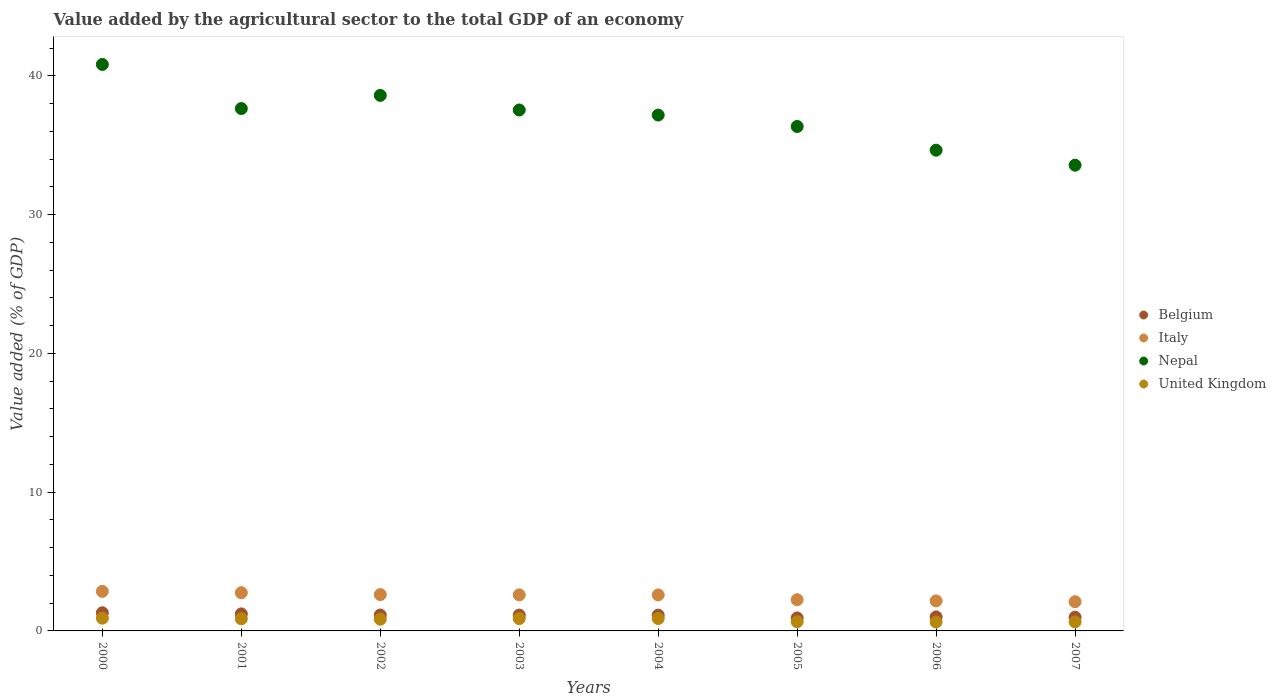Is the number of dotlines equal to the number of legend labels?
Keep it short and to the point. Yes. What is the value added by the agricultural sector to the total GDP in Nepal in 2005?
Ensure brevity in your answer.  36.35. Across all years, what is the maximum value added by the agricultural sector to the total GDP in Belgium?
Your answer should be compact. 1.31. Across all years, what is the minimum value added by the agricultural sector to the total GDP in Nepal?
Your answer should be compact. 33.56. In which year was the value added by the agricultural sector to the total GDP in Nepal maximum?
Offer a very short reply. 2000. What is the total value added by the agricultural sector to the total GDP in Nepal in the graph?
Your answer should be compact. 296.32. What is the difference between the value added by the agricultural sector to the total GDP in Italy in 2001 and that in 2007?
Offer a very short reply. 0.65. What is the difference between the value added by the agricultural sector to the total GDP in United Kingdom in 2006 and the value added by the agricultural sector to the total GDP in Italy in 2001?
Make the answer very short. -2.11. What is the average value added by the agricultural sector to the total GDP in Italy per year?
Your answer should be compact. 2.49. In the year 2003, what is the difference between the value added by the agricultural sector to the total GDP in Italy and value added by the agricultural sector to the total GDP in United Kingdom?
Offer a terse response. 1.71. In how many years, is the value added by the agricultural sector to the total GDP in Nepal greater than 40 %?
Your answer should be compact. 1. What is the ratio of the value added by the agricultural sector to the total GDP in Italy in 2000 to that in 2001?
Provide a short and direct response. 1.03. What is the difference between the highest and the second highest value added by the agricultural sector to the total GDP in United Kingdom?
Make the answer very short. 0.02. What is the difference between the highest and the lowest value added by the agricultural sector to the total GDP in United Kingdom?
Your answer should be compact. 0.28. In how many years, is the value added by the agricultural sector to the total GDP in United Kingdom greater than the average value added by the agricultural sector to the total GDP in United Kingdom taken over all years?
Ensure brevity in your answer.  5. Is the value added by the agricultural sector to the total GDP in Nepal strictly greater than the value added by the agricultural sector to the total GDP in Italy over the years?
Your answer should be compact. Yes. Is the value added by the agricultural sector to the total GDP in Nepal strictly less than the value added by the agricultural sector to the total GDP in Italy over the years?
Offer a terse response. No. How many dotlines are there?
Your response must be concise. 4. Are the values on the major ticks of Y-axis written in scientific E-notation?
Your response must be concise. No. How many legend labels are there?
Provide a succinct answer. 4. How are the legend labels stacked?
Provide a succinct answer. Vertical. What is the title of the graph?
Your answer should be compact. Value added by the agricultural sector to the total GDP of an economy. Does "Caribbean small states" appear as one of the legend labels in the graph?
Your response must be concise. No. What is the label or title of the X-axis?
Provide a short and direct response. Years. What is the label or title of the Y-axis?
Make the answer very short. Value added (% of GDP). What is the Value added (% of GDP) of Belgium in 2000?
Offer a very short reply. 1.31. What is the Value added (% of GDP) of Italy in 2000?
Ensure brevity in your answer.  2.85. What is the Value added (% of GDP) in Nepal in 2000?
Make the answer very short. 40.82. What is the Value added (% of GDP) in United Kingdom in 2000?
Make the answer very short. 0.92. What is the Value added (% of GDP) of Belgium in 2001?
Keep it short and to the point. 1.23. What is the Value added (% of GDP) of Italy in 2001?
Your answer should be very brief. 2.75. What is the Value added (% of GDP) in Nepal in 2001?
Keep it short and to the point. 37.64. What is the Value added (% of GDP) in United Kingdom in 2001?
Your answer should be compact. 0.87. What is the Value added (% of GDP) of Belgium in 2002?
Provide a succinct answer. 1.15. What is the Value added (% of GDP) of Italy in 2002?
Ensure brevity in your answer.  2.62. What is the Value added (% of GDP) in Nepal in 2002?
Give a very brief answer. 38.59. What is the Value added (% of GDP) of United Kingdom in 2002?
Your answer should be compact. 0.84. What is the Value added (% of GDP) in Belgium in 2003?
Your answer should be compact. 1.14. What is the Value added (% of GDP) of Italy in 2003?
Ensure brevity in your answer.  2.6. What is the Value added (% of GDP) in Nepal in 2003?
Your answer should be very brief. 37.54. What is the Value added (% of GDP) in United Kingdom in 2003?
Your response must be concise. 0.89. What is the Value added (% of GDP) in Belgium in 2004?
Give a very brief answer. 1.14. What is the Value added (% of GDP) of Italy in 2004?
Keep it short and to the point. 2.6. What is the Value added (% of GDP) of Nepal in 2004?
Offer a terse response. 37.17. What is the Value added (% of GDP) in United Kingdom in 2004?
Provide a short and direct response. 0.89. What is the Value added (% of GDP) in Belgium in 2005?
Make the answer very short. 0.94. What is the Value added (% of GDP) in Italy in 2005?
Offer a terse response. 2.25. What is the Value added (% of GDP) in Nepal in 2005?
Offer a terse response. 36.35. What is the Value added (% of GDP) of United Kingdom in 2005?
Keep it short and to the point. 0.66. What is the Value added (% of GDP) in Belgium in 2006?
Give a very brief answer. 1.01. What is the Value added (% of GDP) in Italy in 2006?
Your answer should be compact. 2.16. What is the Value added (% of GDP) in Nepal in 2006?
Give a very brief answer. 34.64. What is the Value added (% of GDP) of United Kingdom in 2006?
Keep it short and to the point. 0.64. What is the Value added (% of GDP) in Belgium in 2007?
Your answer should be very brief. 0.99. What is the Value added (% of GDP) of Italy in 2007?
Make the answer very short. 2.1. What is the Value added (% of GDP) of Nepal in 2007?
Your answer should be very brief. 33.56. What is the Value added (% of GDP) in United Kingdom in 2007?
Provide a short and direct response. 0.65. Across all years, what is the maximum Value added (% of GDP) in Belgium?
Your answer should be compact. 1.31. Across all years, what is the maximum Value added (% of GDP) of Italy?
Provide a short and direct response. 2.85. Across all years, what is the maximum Value added (% of GDP) of Nepal?
Give a very brief answer. 40.82. Across all years, what is the maximum Value added (% of GDP) in United Kingdom?
Provide a succinct answer. 0.92. Across all years, what is the minimum Value added (% of GDP) in Belgium?
Provide a short and direct response. 0.94. Across all years, what is the minimum Value added (% of GDP) in Italy?
Provide a short and direct response. 2.1. Across all years, what is the minimum Value added (% of GDP) in Nepal?
Offer a very short reply. 33.56. Across all years, what is the minimum Value added (% of GDP) in United Kingdom?
Keep it short and to the point. 0.64. What is the total Value added (% of GDP) of Belgium in the graph?
Offer a terse response. 8.9. What is the total Value added (% of GDP) of Italy in the graph?
Provide a short and direct response. 19.93. What is the total Value added (% of GDP) in Nepal in the graph?
Ensure brevity in your answer.  296.32. What is the total Value added (% of GDP) of United Kingdom in the graph?
Provide a short and direct response. 6.37. What is the difference between the Value added (% of GDP) of Belgium in 2000 and that in 2001?
Ensure brevity in your answer.  0.08. What is the difference between the Value added (% of GDP) in Italy in 2000 and that in 2001?
Give a very brief answer. 0.1. What is the difference between the Value added (% of GDP) of Nepal in 2000 and that in 2001?
Your answer should be compact. 3.18. What is the difference between the Value added (% of GDP) of United Kingdom in 2000 and that in 2001?
Give a very brief answer. 0.05. What is the difference between the Value added (% of GDP) of Belgium in 2000 and that in 2002?
Offer a terse response. 0.16. What is the difference between the Value added (% of GDP) in Italy in 2000 and that in 2002?
Offer a very short reply. 0.23. What is the difference between the Value added (% of GDP) of Nepal in 2000 and that in 2002?
Offer a very short reply. 2.23. What is the difference between the Value added (% of GDP) in United Kingdom in 2000 and that in 2002?
Make the answer very short. 0.07. What is the difference between the Value added (% of GDP) in Belgium in 2000 and that in 2003?
Offer a very short reply. 0.17. What is the difference between the Value added (% of GDP) in Italy in 2000 and that in 2003?
Keep it short and to the point. 0.25. What is the difference between the Value added (% of GDP) of Nepal in 2000 and that in 2003?
Your response must be concise. 3.28. What is the difference between the Value added (% of GDP) in United Kingdom in 2000 and that in 2003?
Provide a succinct answer. 0.03. What is the difference between the Value added (% of GDP) of Belgium in 2000 and that in 2004?
Offer a terse response. 0.17. What is the difference between the Value added (% of GDP) of Italy in 2000 and that in 2004?
Offer a very short reply. 0.25. What is the difference between the Value added (% of GDP) of Nepal in 2000 and that in 2004?
Provide a succinct answer. 3.65. What is the difference between the Value added (% of GDP) of United Kingdom in 2000 and that in 2004?
Keep it short and to the point. 0.02. What is the difference between the Value added (% of GDP) in Belgium in 2000 and that in 2005?
Your answer should be very brief. 0.37. What is the difference between the Value added (% of GDP) in Italy in 2000 and that in 2005?
Provide a short and direct response. 0.6. What is the difference between the Value added (% of GDP) in Nepal in 2000 and that in 2005?
Offer a very short reply. 4.47. What is the difference between the Value added (% of GDP) in United Kingdom in 2000 and that in 2005?
Your answer should be compact. 0.26. What is the difference between the Value added (% of GDP) of Belgium in 2000 and that in 2006?
Give a very brief answer. 0.3. What is the difference between the Value added (% of GDP) of Italy in 2000 and that in 2006?
Give a very brief answer. 0.68. What is the difference between the Value added (% of GDP) of Nepal in 2000 and that in 2006?
Offer a terse response. 6.18. What is the difference between the Value added (% of GDP) in United Kingdom in 2000 and that in 2006?
Give a very brief answer. 0.28. What is the difference between the Value added (% of GDP) in Belgium in 2000 and that in 2007?
Your answer should be very brief. 0.32. What is the difference between the Value added (% of GDP) in Italy in 2000 and that in 2007?
Your answer should be compact. 0.74. What is the difference between the Value added (% of GDP) of Nepal in 2000 and that in 2007?
Offer a terse response. 7.26. What is the difference between the Value added (% of GDP) of United Kingdom in 2000 and that in 2007?
Your response must be concise. 0.27. What is the difference between the Value added (% of GDP) in Belgium in 2001 and that in 2002?
Your answer should be very brief. 0.08. What is the difference between the Value added (% of GDP) in Italy in 2001 and that in 2002?
Provide a succinct answer. 0.13. What is the difference between the Value added (% of GDP) in Nepal in 2001 and that in 2002?
Your answer should be very brief. -0.95. What is the difference between the Value added (% of GDP) in United Kingdom in 2001 and that in 2002?
Ensure brevity in your answer.  0.03. What is the difference between the Value added (% of GDP) of Belgium in 2001 and that in 2003?
Your answer should be compact. 0.09. What is the difference between the Value added (% of GDP) in Italy in 2001 and that in 2003?
Provide a succinct answer. 0.16. What is the difference between the Value added (% of GDP) of Nepal in 2001 and that in 2003?
Your response must be concise. 0.1. What is the difference between the Value added (% of GDP) of United Kingdom in 2001 and that in 2003?
Your answer should be compact. -0.01. What is the difference between the Value added (% of GDP) of Belgium in 2001 and that in 2004?
Offer a terse response. 0.09. What is the difference between the Value added (% of GDP) in Italy in 2001 and that in 2004?
Offer a very short reply. 0.16. What is the difference between the Value added (% of GDP) in Nepal in 2001 and that in 2004?
Your response must be concise. 0.47. What is the difference between the Value added (% of GDP) of United Kingdom in 2001 and that in 2004?
Offer a very short reply. -0.02. What is the difference between the Value added (% of GDP) of Belgium in 2001 and that in 2005?
Offer a terse response. 0.29. What is the difference between the Value added (% of GDP) of Italy in 2001 and that in 2005?
Make the answer very short. 0.5. What is the difference between the Value added (% of GDP) of Nepal in 2001 and that in 2005?
Offer a very short reply. 1.29. What is the difference between the Value added (% of GDP) of United Kingdom in 2001 and that in 2005?
Provide a succinct answer. 0.21. What is the difference between the Value added (% of GDP) of Belgium in 2001 and that in 2006?
Make the answer very short. 0.22. What is the difference between the Value added (% of GDP) in Italy in 2001 and that in 2006?
Provide a succinct answer. 0.59. What is the difference between the Value added (% of GDP) in Nepal in 2001 and that in 2006?
Keep it short and to the point. 3. What is the difference between the Value added (% of GDP) of United Kingdom in 2001 and that in 2006?
Offer a terse response. 0.23. What is the difference between the Value added (% of GDP) in Belgium in 2001 and that in 2007?
Ensure brevity in your answer.  0.24. What is the difference between the Value added (% of GDP) in Italy in 2001 and that in 2007?
Provide a short and direct response. 0.65. What is the difference between the Value added (% of GDP) in Nepal in 2001 and that in 2007?
Your answer should be compact. 4.08. What is the difference between the Value added (% of GDP) of United Kingdom in 2001 and that in 2007?
Offer a terse response. 0.22. What is the difference between the Value added (% of GDP) in Belgium in 2002 and that in 2003?
Offer a terse response. 0. What is the difference between the Value added (% of GDP) of Italy in 2002 and that in 2003?
Provide a succinct answer. 0.02. What is the difference between the Value added (% of GDP) in Nepal in 2002 and that in 2003?
Make the answer very short. 1.05. What is the difference between the Value added (% of GDP) of United Kingdom in 2002 and that in 2003?
Provide a short and direct response. -0.04. What is the difference between the Value added (% of GDP) of Belgium in 2002 and that in 2004?
Make the answer very short. 0.01. What is the difference between the Value added (% of GDP) in Italy in 2002 and that in 2004?
Offer a terse response. 0.02. What is the difference between the Value added (% of GDP) in Nepal in 2002 and that in 2004?
Offer a terse response. 1.42. What is the difference between the Value added (% of GDP) of Belgium in 2002 and that in 2005?
Your answer should be compact. 0.21. What is the difference between the Value added (% of GDP) in Italy in 2002 and that in 2005?
Your response must be concise. 0.37. What is the difference between the Value added (% of GDP) of Nepal in 2002 and that in 2005?
Provide a short and direct response. 2.24. What is the difference between the Value added (% of GDP) in United Kingdom in 2002 and that in 2005?
Provide a short and direct response. 0.18. What is the difference between the Value added (% of GDP) in Belgium in 2002 and that in 2006?
Your answer should be very brief. 0.13. What is the difference between the Value added (% of GDP) in Italy in 2002 and that in 2006?
Make the answer very short. 0.45. What is the difference between the Value added (% of GDP) of Nepal in 2002 and that in 2006?
Provide a short and direct response. 3.95. What is the difference between the Value added (% of GDP) in United Kingdom in 2002 and that in 2006?
Your answer should be very brief. 0.2. What is the difference between the Value added (% of GDP) of Belgium in 2002 and that in 2007?
Make the answer very short. 0.15. What is the difference between the Value added (% of GDP) of Italy in 2002 and that in 2007?
Provide a succinct answer. 0.52. What is the difference between the Value added (% of GDP) of Nepal in 2002 and that in 2007?
Your response must be concise. 5.03. What is the difference between the Value added (% of GDP) in United Kingdom in 2002 and that in 2007?
Ensure brevity in your answer.  0.19. What is the difference between the Value added (% of GDP) of Belgium in 2003 and that in 2004?
Offer a terse response. 0. What is the difference between the Value added (% of GDP) of Italy in 2003 and that in 2004?
Your answer should be compact. 0. What is the difference between the Value added (% of GDP) in Nepal in 2003 and that in 2004?
Offer a terse response. 0.37. What is the difference between the Value added (% of GDP) in United Kingdom in 2003 and that in 2004?
Provide a short and direct response. -0.01. What is the difference between the Value added (% of GDP) in Belgium in 2003 and that in 2005?
Offer a very short reply. 0.2. What is the difference between the Value added (% of GDP) of Italy in 2003 and that in 2005?
Offer a terse response. 0.35. What is the difference between the Value added (% of GDP) in Nepal in 2003 and that in 2005?
Your response must be concise. 1.19. What is the difference between the Value added (% of GDP) of United Kingdom in 2003 and that in 2005?
Provide a short and direct response. 0.22. What is the difference between the Value added (% of GDP) in Belgium in 2003 and that in 2006?
Offer a terse response. 0.13. What is the difference between the Value added (% of GDP) of Italy in 2003 and that in 2006?
Your answer should be very brief. 0.43. What is the difference between the Value added (% of GDP) of Nepal in 2003 and that in 2006?
Your answer should be very brief. 2.9. What is the difference between the Value added (% of GDP) of United Kingdom in 2003 and that in 2006?
Provide a succinct answer. 0.24. What is the difference between the Value added (% of GDP) in Belgium in 2003 and that in 2007?
Your answer should be compact. 0.15. What is the difference between the Value added (% of GDP) in Italy in 2003 and that in 2007?
Your answer should be very brief. 0.49. What is the difference between the Value added (% of GDP) in Nepal in 2003 and that in 2007?
Your response must be concise. 3.98. What is the difference between the Value added (% of GDP) of United Kingdom in 2003 and that in 2007?
Your answer should be very brief. 0.24. What is the difference between the Value added (% of GDP) in Belgium in 2004 and that in 2005?
Ensure brevity in your answer.  0.2. What is the difference between the Value added (% of GDP) of Italy in 2004 and that in 2005?
Provide a succinct answer. 0.35. What is the difference between the Value added (% of GDP) in Nepal in 2004 and that in 2005?
Provide a short and direct response. 0.82. What is the difference between the Value added (% of GDP) in United Kingdom in 2004 and that in 2005?
Your answer should be very brief. 0.23. What is the difference between the Value added (% of GDP) of Belgium in 2004 and that in 2006?
Your response must be concise. 0.13. What is the difference between the Value added (% of GDP) of Italy in 2004 and that in 2006?
Your answer should be very brief. 0.43. What is the difference between the Value added (% of GDP) in Nepal in 2004 and that in 2006?
Give a very brief answer. 2.53. What is the difference between the Value added (% of GDP) in United Kingdom in 2004 and that in 2006?
Your answer should be very brief. 0.25. What is the difference between the Value added (% of GDP) in Belgium in 2004 and that in 2007?
Keep it short and to the point. 0.15. What is the difference between the Value added (% of GDP) of Italy in 2004 and that in 2007?
Your response must be concise. 0.49. What is the difference between the Value added (% of GDP) of Nepal in 2004 and that in 2007?
Offer a terse response. 3.61. What is the difference between the Value added (% of GDP) in United Kingdom in 2004 and that in 2007?
Provide a succinct answer. 0.24. What is the difference between the Value added (% of GDP) of Belgium in 2005 and that in 2006?
Your response must be concise. -0.08. What is the difference between the Value added (% of GDP) in Italy in 2005 and that in 2006?
Make the answer very short. 0.08. What is the difference between the Value added (% of GDP) in Nepal in 2005 and that in 2006?
Provide a short and direct response. 1.71. What is the difference between the Value added (% of GDP) of United Kingdom in 2005 and that in 2006?
Give a very brief answer. 0.02. What is the difference between the Value added (% of GDP) in Belgium in 2005 and that in 2007?
Offer a terse response. -0.05. What is the difference between the Value added (% of GDP) of Italy in 2005 and that in 2007?
Offer a very short reply. 0.14. What is the difference between the Value added (% of GDP) of Nepal in 2005 and that in 2007?
Give a very brief answer. 2.79. What is the difference between the Value added (% of GDP) of United Kingdom in 2005 and that in 2007?
Give a very brief answer. 0.01. What is the difference between the Value added (% of GDP) of Belgium in 2006 and that in 2007?
Your answer should be compact. 0.02. What is the difference between the Value added (% of GDP) in Italy in 2006 and that in 2007?
Your answer should be compact. 0.06. What is the difference between the Value added (% of GDP) of Nepal in 2006 and that in 2007?
Offer a terse response. 1.08. What is the difference between the Value added (% of GDP) of United Kingdom in 2006 and that in 2007?
Ensure brevity in your answer.  -0.01. What is the difference between the Value added (% of GDP) of Belgium in 2000 and the Value added (% of GDP) of Italy in 2001?
Give a very brief answer. -1.44. What is the difference between the Value added (% of GDP) of Belgium in 2000 and the Value added (% of GDP) of Nepal in 2001?
Give a very brief answer. -36.33. What is the difference between the Value added (% of GDP) of Belgium in 2000 and the Value added (% of GDP) of United Kingdom in 2001?
Your answer should be very brief. 0.44. What is the difference between the Value added (% of GDP) in Italy in 2000 and the Value added (% of GDP) in Nepal in 2001?
Ensure brevity in your answer.  -34.79. What is the difference between the Value added (% of GDP) of Italy in 2000 and the Value added (% of GDP) of United Kingdom in 2001?
Your answer should be very brief. 1.98. What is the difference between the Value added (% of GDP) in Nepal in 2000 and the Value added (% of GDP) in United Kingdom in 2001?
Provide a short and direct response. 39.95. What is the difference between the Value added (% of GDP) of Belgium in 2000 and the Value added (% of GDP) of Italy in 2002?
Ensure brevity in your answer.  -1.31. What is the difference between the Value added (% of GDP) in Belgium in 2000 and the Value added (% of GDP) in Nepal in 2002?
Give a very brief answer. -37.28. What is the difference between the Value added (% of GDP) of Belgium in 2000 and the Value added (% of GDP) of United Kingdom in 2002?
Your answer should be very brief. 0.47. What is the difference between the Value added (% of GDP) of Italy in 2000 and the Value added (% of GDP) of Nepal in 2002?
Provide a short and direct response. -35.74. What is the difference between the Value added (% of GDP) in Italy in 2000 and the Value added (% of GDP) in United Kingdom in 2002?
Provide a short and direct response. 2. What is the difference between the Value added (% of GDP) of Nepal in 2000 and the Value added (% of GDP) of United Kingdom in 2002?
Provide a succinct answer. 39.98. What is the difference between the Value added (% of GDP) in Belgium in 2000 and the Value added (% of GDP) in Italy in 2003?
Make the answer very short. -1.29. What is the difference between the Value added (% of GDP) of Belgium in 2000 and the Value added (% of GDP) of Nepal in 2003?
Provide a short and direct response. -36.23. What is the difference between the Value added (% of GDP) of Belgium in 2000 and the Value added (% of GDP) of United Kingdom in 2003?
Give a very brief answer. 0.42. What is the difference between the Value added (% of GDP) of Italy in 2000 and the Value added (% of GDP) of Nepal in 2003?
Give a very brief answer. -34.69. What is the difference between the Value added (% of GDP) in Italy in 2000 and the Value added (% of GDP) in United Kingdom in 2003?
Provide a short and direct response. 1.96. What is the difference between the Value added (% of GDP) of Nepal in 2000 and the Value added (% of GDP) of United Kingdom in 2003?
Make the answer very short. 39.93. What is the difference between the Value added (% of GDP) of Belgium in 2000 and the Value added (% of GDP) of Italy in 2004?
Your response must be concise. -1.29. What is the difference between the Value added (% of GDP) of Belgium in 2000 and the Value added (% of GDP) of Nepal in 2004?
Provide a succinct answer. -35.86. What is the difference between the Value added (% of GDP) of Belgium in 2000 and the Value added (% of GDP) of United Kingdom in 2004?
Ensure brevity in your answer.  0.42. What is the difference between the Value added (% of GDP) of Italy in 2000 and the Value added (% of GDP) of Nepal in 2004?
Offer a very short reply. -34.33. What is the difference between the Value added (% of GDP) of Italy in 2000 and the Value added (% of GDP) of United Kingdom in 2004?
Make the answer very short. 1.95. What is the difference between the Value added (% of GDP) in Nepal in 2000 and the Value added (% of GDP) in United Kingdom in 2004?
Give a very brief answer. 39.93. What is the difference between the Value added (% of GDP) in Belgium in 2000 and the Value added (% of GDP) in Italy in 2005?
Make the answer very short. -0.94. What is the difference between the Value added (% of GDP) in Belgium in 2000 and the Value added (% of GDP) in Nepal in 2005?
Offer a very short reply. -35.04. What is the difference between the Value added (% of GDP) in Belgium in 2000 and the Value added (% of GDP) in United Kingdom in 2005?
Ensure brevity in your answer.  0.65. What is the difference between the Value added (% of GDP) in Italy in 2000 and the Value added (% of GDP) in Nepal in 2005?
Offer a terse response. -33.5. What is the difference between the Value added (% of GDP) in Italy in 2000 and the Value added (% of GDP) in United Kingdom in 2005?
Ensure brevity in your answer.  2.19. What is the difference between the Value added (% of GDP) in Nepal in 2000 and the Value added (% of GDP) in United Kingdom in 2005?
Provide a succinct answer. 40.16. What is the difference between the Value added (% of GDP) of Belgium in 2000 and the Value added (% of GDP) of Italy in 2006?
Give a very brief answer. -0.86. What is the difference between the Value added (% of GDP) in Belgium in 2000 and the Value added (% of GDP) in Nepal in 2006?
Your answer should be very brief. -33.33. What is the difference between the Value added (% of GDP) in Belgium in 2000 and the Value added (% of GDP) in United Kingdom in 2006?
Your answer should be compact. 0.67. What is the difference between the Value added (% of GDP) of Italy in 2000 and the Value added (% of GDP) of Nepal in 2006?
Your answer should be compact. -31.79. What is the difference between the Value added (% of GDP) in Italy in 2000 and the Value added (% of GDP) in United Kingdom in 2006?
Give a very brief answer. 2.21. What is the difference between the Value added (% of GDP) of Nepal in 2000 and the Value added (% of GDP) of United Kingdom in 2006?
Keep it short and to the point. 40.18. What is the difference between the Value added (% of GDP) of Belgium in 2000 and the Value added (% of GDP) of Italy in 2007?
Provide a succinct answer. -0.8. What is the difference between the Value added (% of GDP) in Belgium in 2000 and the Value added (% of GDP) in Nepal in 2007?
Your answer should be compact. -32.25. What is the difference between the Value added (% of GDP) of Belgium in 2000 and the Value added (% of GDP) of United Kingdom in 2007?
Your answer should be compact. 0.66. What is the difference between the Value added (% of GDP) in Italy in 2000 and the Value added (% of GDP) in Nepal in 2007?
Give a very brief answer. -30.71. What is the difference between the Value added (% of GDP) of Italy in 2000 and the Value added (% of GDP) of United Kingdom in 2007?
Provide a short and direct response. 2.2. What is the difference between the Value added (% of GDP) of Nepal in 2000 and the Value added (% of GDP) of United Kingdom in 2007?
Your response must be concise. 40.17. What is the difference between the Value added (% of GDP) in Belgium in 2001 and the Value added (% of GDP) in Italy in 2002?
Your answer should be very brief. -1.39. What is the difference between the Value added (% of GDP) in Belgium in 2001 and the Value added (% of GDP) in Nepal in 2002?
Ensure brevity in your answer.  -37.36. What is the difference between the Value added (% of GDP) of Belgium in 2001 and the Value added (% of GDP) of United Kingdom in 2002?
Provide a succinct answer. 0.39. What is the difference between the Value added (% of GDP) of Italy in 2001 and the Value added (% of GDP) of Nepal in 2002?
Ensure brevity in your answer.  -35.84. What is the difference between the Value added (% of GDP) of Italy in 2001 and the Value added (% of GDP) of United Kingdom in 2002?
Provide a short and direct response. 1.91. What is the difference between the Value added (% of GDP) of Nepal in 2001 and the Value added (% of GDP) of United Kingdom in 2002?
Provide a succinct answer. 36.8. What is the difference between the Value added (% of GDP) in Belgium in 2001 and the Value added (% of GDP) in Italy in 2003?
Your answer should be very brief. -1.37. What is the difference between the Value added (% of GDP) in Belgium in 2001 and the Value added (% of GDP) in Nepal in 2003?
Your response must be concise. -36.31. What is the difference between the Value added (% of GDP) of Belgium in 2001 and the Value added (% of GDP) of United Kingdom in 2003?
Ensure brevity in your answer.  0.34. What is the difference between the Value added (% of GDP) of Italy in 2001 and the Value added (% of GDP) of Nepal in 2003?
Your response must be concise. -34.79. What is the difference between the Value added (% of GDP) of Italy in 2001 and the Value added (% of GDP) of United Kingdom in 2003?
Your answer should be compact. 1.87. What is the difference between the Value added (% of GDP) of Nepal in 2001 and the Value added (% of GDP) of United Kingdom in 2003?
Your answer should be compact. 36.76. What is the difference between the Value added (% of GDP) of Belgium in 2001 and the Value added (% of GDP) of Italy in 2004?
Provide a succinct answer. -1.37. What is the difference between the Value added (% of GDP) in Belgium in 2001 and the Value added (% of GDP) in Nepal in 2004?
Offer a very short reply. -35.94. What is the difference between the Value added (% of GDP) of Belgium in 2001 and the Value added (% of GDP) of United Kingdom in 2004?
Offer a terse response. 0.34. What is the difference between the Value added (% of GDP) of Italy in 2001 and the Value added (% of GDP) of Nepal in 2004?
Your answer should be very brief. -34.42. What is the difference between the Value added (% of GDP) in Italy in 2001 and the Value added (% of GDP) in United Kingdom in 2004?
Give a very brief answer. 1.86. What is the difference between the Value added (% of GDP) in Nepal in 2001 and the Value added (% of GDP) in United Kingdom in 2004?
Ensure brevity in your answer.  36.75. What is the difference between the Value added (% of GDP) in Belgium in 2001 and the Value added (% of GDP) in Italy in 2005?
Your answer should be compact. -1.02. What is the difference between the Value added (% of GDP) of Belgium in 2001 and the Value added (% of GDP) of Nepal in 2005?
Offer a terse response. -35.12. What is the difference between the Value added (% of GDP) in Belgium in 2001 and the Value added (% of GDP) in United Kingdom in 2005?
Offer a terse response. 0.57. What is the difference between the Value added (% of GDP) of Italy in 2001 and the Value added (% of GDP) of Nepal in 2005?
Your response must be concise. -33.6. What is the difference between the Value added (% of GDP) in Italy in 2001 and the Value added (% of GDP) in United Kingdom in 2005?
Your answer should be compact. 2.09. What is the difference between the Value added (% of GDP) of Nepal in 2001 and the Value added (% of GDP) of United Kingdom in 2005?
Ensure brevity in your answer.  36.98. What is the difference between the Value added (% of GDP) in Belgium in 2001 and the Value added (% of GDP) in Italy in 2006?
Provide a short and direct response. -0.93. What is the difference between the Value added (% of GDP) of Belgium in 2001 and the Value added (% of GDP) of Nepal in 2006?
Provide a short and direct response. -33.41. What is the difference between the Value added (% of GDP) in Belgium in 2001 and the Value added (% of GDP) in United Kingdom in 2006?
Offer a terse response. 0.59. What is the difference between the Value added (% of GDP) of Italy in 2001 and the Value added (% of GDP) of Nepal in 2006?
Offer a terse response. -31.89. What is the difference between the Value added (% of GDP) in Italy in 2001 and the Value added (% of GDP) in United Kingdom in 2006?
Your answer should be compact. 2.11. What is the difference between the Value added (% of GDP) in Nepal in 2001 and the Value added (% of GDP) in United Kingdom in 2006?
Offer a terse response. 37. What is the difference between the Value added (% of GDP) in Belgium in 2001 and the Value added (% of GDP) in Italy in 2007?
Offer a terse response. -0.87. What is the difference between the Value added (% of GDP) in Belgium in 2001 and the Value added (% of GDP) in Nepal in 2007?
Your answer should be compact. -32.33. What is the difference between the Value added (% of GDP) in Belgium in 2001 and the Value added (% of GDP) in United Kingdom in 2007?
Ensure brevity in your answer.  0.58. What is the difference between the Value added (% of GDP) in Italy in 2001 and the Value added (% of GDP) in Nepal in 2007?
Make the answer very short. -30.81. What is the difference between the Value added (% of GDP) in Italy in 2001 and the Value added (% of GDP) in United Kingdom in 2007?
Your answer should be compact. 2.1. What is the difference between the Value added (% of GDP) in Nepal in 2001 and the Value added (% of GDP) in United Kingdom in 2007?
Give a very brief answer. 36.99. What is the difference between the Value added (% of GDP) of Belgium in 2002 and the Value added (% of GDP) of Italy in 2003?
Offer a terse response. -1.45. What is the difference between the Value added (% of GDP) in Belgium in 2002 and the Value added (% of GDP) in Nepal in 2003?
Give a very brief answer. -36.39. What is the difference between the Value added (% of GDP) in Belgium in 2002 and the Value added (% of GDP) in United Kingdom in 2003?
Ensure brevity in your answer.  0.26. What is the difference between the Value added (% of GDP) in Italy in 2002 and the Value added (% of GDP) in Nepal in 2003?
Offer a terse response. -34.92. What is the difference between the Value added (% of GDP) of Italy in 2002 and the Value added (% of GDP) of United Kingdom in 2003?
Your response must be concise. 1.73. What is the difference between the Value added (% of GDP) in Nepal in 2002 and the Value added (% of GDP) in United Kingdom in 2003?
Make the answer very short. 37.7. What is the difference between the Value added (% of GDP) in Belgium in 2002 and the Value added (% of GDP) in Italy in 2004?
Make the answer very short. -1.45. What is the difference between the Value added (% of GDP) of Belgium in 2002 and the Value added (% of GDP) of Nepal in 2004?
Your answer should be compact. -36.03. What is the difference between the Value added (% of GDP) in Belgium in 2002 and the Value added (% of GDP) in United Kingdom in 2004?
Keep it short and to the point. 0.25. What is the difference between the Value added (% of GDP) of Italy in 2002 and the Value added (% of GDP) of Nepal in 2004?
Make the answer very short. -34.55. What is the difference between the Value added (% of GDP) in Italy in 2002 and the Value added (% of GDP) in United Kingdom in 2004?
Provide a succinct answer. 1.73. What is the difference between the Value added (% of GDP) of Nepal in 2002 and the Value added (% of GDP) of United Kingdom in 2004?
Ensure brevity in your answer.  37.7. What is the difference between the Value added (% of GDP) of Belgium in 2002 and the Value added (% of GDP) of Italy in 2005?
Your answer should be compact. -1.1. What is the difference between the Value added (% of GDP) in Belgium in 2002 and the Value added (% of GDP) in Nepal in 2005?
Provide a succinct answer. -35.2. What is the difference between the Value added (% of GDP) of Belgium in 2002 and the Value added (% of GDP) of United Kingdom in 2005?
Give a very brief answer. 0.48. What is the difference between the Value added (% of GDP) in Italy in 2002 and the Value added (% of GDP) in Nepal in 2005?
Ensure brevity in your answer.  -33.73. What is the difference between the Value added (% of GDP) of Italy in 2002 and the Value added (% of GDP) of United Kingdom in 2005?
Your answer should be very brief. 1.96. What is the difference between the Value added (% of GDP) of Nepal in 2002 and the Value added (% of GDP) of United Kingdom in 2005?
Give a very brief answer. 37.93. What is the difference between the Value added (% of GDP) of Belgium in 2002 and the Value added (% of GDP) of Italy in 2006?
Provide a succinct answer. -1.02. What is the difference between the Value added (% of GDP) of Belgium in 2002 and the Value added (% of GDP) of Nepal in 2006?
Offer a terse response. -33.5. What is the difference between the Value added (% of GDP) of Belgium in 2002 and the Value added (% of GDP) of United Kingdom in 2006?
Give a very brief answer. 0.5. What is the difference between the Value added (% of GDP) in Italy in 2002 and the Value added (% of GDP) in Nepal in 2006?
Your response must be concise. -32.02. What is the difference between the Value added (% of GDP) of Italy in 2002 and the Value added (% of GDP) of United Kingdom in 2006?
Your response must be concise. 1.98. What is the difference between the Value added (% of GDP) in Nepal in 2002 and the Value added (% of GDP) in United Kingdom in 2006?
Offer a very short reply. 37.95. What is the difference between the Value added (% of GDP) of Belgium in 2002 and the Value added (% of GDP) of Italy in 2007?
Your response must be concise. -0.96. What is the difference between the Value added (% of GDP) in Belgium in 2002 and the Value added (% of GDP) in Nepal in 2007?
Your answer should be compact. -32.42. What is the difference between the Value added (% of GDP) of Belgium in 2002 and the Value added (% of GDP) of United Kingdom in 2007?
Your answer should be very brief. 0.5. What is the difference between the Value added (% of GDP) of Italy in 2002 and the Value added (% of GDP) of Nepal in 2007?
Your answer should be very brief. -30.94. What is the difference between the Value added (% of GDP) in Italy in 2002 and the Value added (% of GDP) in United Kingdom in 2007?
Your answer should be very brief. 1.97. What is the difference between the Value added (% of GDP) in Nepal in 2002 and the Value added (% of GDP) in United Kingdom in 2007?
Give a very brief answer. 37.94. What is the difference between the Value added (% of GDP) of Belgium in 2003 and the Value added (% of GDP) of Italy in 2004?
Make the answer very short. -1.45. What is the difference between the Value added (% of GDP) of Belgium in 2003 and the Value added (% of GDP) of Nepal in 2004?
Provide a short and direct response. -36.03. What is the difference between the Value added (% of GDP) in Belgium in 2003 and the Value added (% of GDP) in United Kingdom in 2004?
Provide a short and direct response. 0.25. What is the difference between the Value added (% of GDP) in Italy in 2003 and the Value added (% of GDP) in Nepal in 2004?
Your response must be concise. -34.58. What is the difference between the Value added (% of GDP) in Italy in 2003 and the Value added (% of GDP) in United Kingdom in 2004?
Provide a short and direct response. 1.7. What is the difference between the Value added (% of GDP) in Nepal in 2003 and the Value added (% of GDP) in United Kingdom in 2004?
Your answer should be compact. 36.65. What is the difference between the Value added (% of GDP) in Belgium in 2003 and the Value added (% of GDP) in Italy in 2005?
Ensure brevity in your answer.  -1.11. What is the difference between the Value added (% of GDP) of Belgium in 2003 and the Value added (% of GDP) of Nepal in 2005?
Keep it short and to the point. -35.21. What is the difference between the Value added (% of GDP) in Belgium in 2003 and the Value added (% of GDP) in United Kingdom in 2005?
Provide a short and direct response. 0.48. What is the difference between the Value added (% of GDP) of Italy in 2003 and the Value added (% of GDP) of Nepal in 2005?
Offer a terse response. -33.75. What is the difference between the Value added (% of GDP) in Italy in 2003 and the Value added (% of GDP) in United Kingdom in 2005?
Your response must be concise. 1.93. What is the difference between the Value added (% of GDP) of Nepal in 2003 and the Value added (% of GDP) of United Kingdom in 2005?
Offer a very short reply. 36.88. What is the difference between the Value added (% of GDP) of Belgium in 2003 and the Value added (% of GDP) of Italy in 2006?
Your answer should be compact. -1.02. What is the difference between the Value added (% of GDP) of Belgium in 2003 and the Value added (% of GDP) of Nepal in 2006?
Your answer should be very brief. -33.5. What is the difference between the Value added (% of GDP) of Belgium in 2003 and the Value added (% of GDP) of United Kingdom in 2006?
Your response must be concise. 0.5. What is the difference between the Value added (% of GDP) of Italy in 2003 and the Value added (% of GDP) of Nepal in 2006?
Ensure brevity in your answer.  -32.05. What is the difference between the Value added (% of GDP) in Italy in 2003 and the Value added (% of GDP) in United Kingdom in 2006?
Give a very brief answer. 1.95. What is the difference between the Value added (% of GDP) in Nepal in 2003 and the Value added (% of GDP) in United Kingdom in 2006?
Give a very brief answer. 36.9. What is the difference between the Value added (% of GDP) of Belgium in 2003 and the Value added (% of GDP) of Italy in 2007?
Give a very brief answer. -0.96. What is the difference between the Value added (% of GDP) of Belgium in 2003 and the Value added (% of GDP) of Nepal in 2007?
Make the answer very short. -32.42. What is the difference between the Value added (% of GDP) in Belgium in 2003 and the Value added (% of GDP) in United Kingdom in 2007?
Ensure brevity in your answer.  0.49. What is the difference between the Value added (% of GDP) of Italy in 2003 and the Value added (% of GDP) of Nepal in 2007?
Your response must be concise. -30.96. What is the difference between the Value added (% of GDP) in Italy in 2003 and the Value added (% of GDP) in United Kingdom in 2007?
Your answer should be very brief. 1.95. What is the difference between the Value added (% of GDP) in Nepal in 2003 and the Value added (% of GDP) in United Kingdom in 2007?
Your answer should be compact. 36.89. What is the difference between the Value added (% of GDP) in Belgium in 2004 and the Value added (% of GDP) in Italy in 2005?
Ensure brevity in your answer.  -1.11. What is the difference between the Value added (% of GDP) of Belgium in 2004 and the Value added (% of GDP) of Nepal in 2005?
Your answer should be compact. -35.21. What is the difference between the Value added (% of GDP) of Belgium in 2004 and the Value added (% of GDP) of United Kingdom in 2005?
Provide a succinct answer. 0.47. What is the difference between the Value added (% of GDP) of Italy in 2004 and the Value added (% of GDP) of Nepal in 2005?
Your answer should be compact. -33.75. What is the difference between the Value added (% of GDP) of Italy in 2004 and the Value added (% of GDP) of United Kingdom in 2005?
Provide a succinct answer. 1.93. What is the difference between the Value added (% of GDP) in Nepal in 2004 and the Value added (% of GDP) in United Kingdom in 2005?
Offer a very short reply. 36.51. What is the difference between the Value added (% of GDP) in Belgium in 2004 and the Value added (% of GDP) in Italy in 2006?
Give a very brief answer. -1.03. What is the difference between the Value added (% of GDP) of Belgium in 2004 and the Value added (% of GDP) of Nepal in 2006?
Provide a short and direct response. -33.5. What is the difference between the Value added (% of GDP) in Belgium in 2004 and the Value added (% of GDP) in United Kingdom in 2006?
Keep it short and to the point. 0.5. What is the difference between the Value added (% of GDP) of Italy in 2004 and the Value added (% of GDP) of Nepal in 2006?
Your response must be concise. -32.05. What is the difference between the Value added (% of GDP) of Italy in 2004 and the Value added (% of GDP) of United Kingdom in 2006?
Keep it short and to the point. 1.95. What is the difference between the Value added (% of GDP) in Nepal in 2004 and the Value added (% of GDP) in United Kingdom in 2006?
Offer a terse response. 36.53. What is the difference between the Value added (% of GDP) of Belgium in 2004 and the Value added (% of GDP) of Italy in 2007?
Ensure brevity in your answer.  -0.97. What is the difference between the Value added (% of GDP) of Belgium in 2004 and the Value added (% of GDP) of Nepal in 2007?
Your response must be concise. -32.42. What is the difference between the Value added (% of GDP) in Belgium in 2004 and the Value added (% of GDP) in United Kingdom in 2007?
Give a very brief answer. 0.49. What is the difference between the Value added (% of GDP) of Italy in 2004 and the Value added (% of GDP) of Nepal in 2007?
Offer a very short reply. -30.96. What is the difference between the Value added (% of GDP) of Italy in 2004 and the Value added (% of GDP) of United Kingdom in 2007?
Offer a terse response. 1.95. What is the difference between the Value added (% of GDP) in Nepal in 2004 and the Value added (% of GDP) in United Kingdom in 2007?
Provide a succinct answer. 36.52. What is the difference between the Value added (% of GDP) in Belgium in 2005 and the Value added (% of GDP) in Italy in 2006?
Give a very brief answer. -1.23. What is the difference between the Value added (% of GDP) in Belgium in 2005 and the Value added (% of GDP) in Nepal in 2006?
Your answer should be very brief. -33.71. What is the difference between the Value added (% of GDP) of Belgium in 2005 and the Value added (% of GDP) of United Kingdom in 2006?
Your answer should be compact. 0.29. What is the difference between the Value added (% of GDP) of Italy in 2005 and the Value added (% of GDP) of Nepal in 2006?
Make the answer very short. -32.39. What is the difference between the Value added (% of GDP) in Italy in 2005 and the Value added (% of GDP) in United Kingdom in 2006?
Keep it short and to the point. 1.61. What is the difference between the Value added (% of GDP) in Nepal in 2005 and the Value added (% of GDP) in United Kingdom in 2006?
Make the answer very short. 35.71. What is the difference between the Value added (% of GDP) of Belgium in 2005 and the Value added (% of GDP) of Italy in 2007?
Your response must be concise. -1.17. What is the difference between the Value added (% of GDP) in Belgium in 2005 and the Value added (% of GDP) in Nepal in 2007?
Provide a succinct answer. -32.62. What is the difference between the Value added (% of GDP) in Belgium in 2005 and the Value added (% of GDP) in United Kingdom in 2007?
Give a very brief answer. 0.29. What is the difference between the Value added (% of GDP) in Italy in 2005 and the Value added (% of GDP) in Nepal in 2007?
Keep it short and to the point. -31.31. What is the difference between the Value added (% of GDP) in Italy in 2005 and the Value added (% of GDP) in United Kingdom in 2007?
Provide a short and direct response. 1.6. What is the difference between the Value added (% of GDP) in Nepal in 2005 and the Value added (% of GDP) in United Kingdom in 2007?
Your answer should be very brief. 35.7. What is the difference between the Value added (% of GDP) of Belgium in 2006 and the Value added (% of GDP) of Italy in 2007?
Ensure brevity in your answer.  -1.09. What is the difference between the Value added (% of GDP) of Belgium in 2006 and the Value added (% of GDP) of Nepal in 2007?
Provide a short and direct response. -32.55. What is the difference between the Value added (% of GDP) of Belgium in 2006 and the Value added (% of GDP) of United Kingdom in 2007?
Your response must be concise. 0.36. What is the difference between the Value added (% of GDP) in Italy in 2006 and the Value added (% of GDP) in Nepal in 2007?
Your answer should be very brief. -31.4. What is the difference between the Value added (% of GDP) in Italy in 2006 and the Value added (% of GDP) in United Kingdom in 2007?
Keep it short and to the point. 1.52. What is the difference between the Value added (% of GDP) in Nepal in 2006 and the Value added (% of GDP) in United Kingdom in 2007?
Your response must be concise. 33.99. What is the average Value added (% of GDP) in Belgium per year?
Make the answer very short. 1.11. What is the average Value added (% of GDP) in Italy per year?
Your response must be concise. 2.49. What is the average Value added (% of GDP) of Nepal per year?
Your response must be concise. 37.04. What is the average Value added (% of GDP) of United Kingdom per year?
Offer a very short reply. 0.8. In the year 2000, what is the difference between the Value added (% of GDP) in Belgium and Value added (% of GDP) in Italy?
Offer a very short reply. -1.54. In the year 2000, what is the difference between the Value added (% of GDP) in Belgium and Value added (% of GDP) in Nepal?
Provide a succinct answer. -39.51. In the year 2000, what is the difference between the Value added (% of GDP) in Belgium and Value added (% of GDP) in United Kingdom?
Ensure brevity in your answer.  0.39. In the year 2000, what is the difference between the Value added (% of GDP) in Italy and Value added (% of GDP) in Nepal?
Provide a short and direct response. -37.97. In the year 2000, what is the difference between the Value added (% of GDP) of Italy and Value added (% of GDP) of United Kingdom?
Keep it short and to the point. 1.93. In the year 2000, what is the difference between the Value added (% of GDP) of Nepal and Value added (% of GDP) of United Kingdom?
Offer a terse response. 39.9. In the year 2001, what is the difference between the Value added (% of GDP) of Belgium and Value added (% of GDP) of Italy?
Offer a very short reply. -1.52. In the year 2001, what is the difference between the Value added (% of GDP) of Belgium and Value added (% of GDP) of Nepal?
Offer a terse response. -36.41. In the year 2001, what is the difference between the Value added (% of GDP) in Belgium and Value added (% of GDP) in United Kingdom?
Provide a short and direct response. 0.36. In the year 2001, what is the difference between the Value added (% of GDP) of Italy and Value added (% of GDP) of Nepal?
Offer a very short reply. -34.89. In the year 2001, what is the difference between the Value added (% of GDP) of Italy and Value added (% of GDP) of United Kingdom?
Ensure brevity in your answer.  1.88. In the year 2001, what is the difference between the Value added (% of GDP) in Nepal and Value added (% of GDP) in United Kingdom?
Ensure brevity in your answer.  36.77. In the year 2002, what is the difference between the Value added (% of GDP) in Belgium and Value added (% of GDP) in Italy?
Provide a short and direct response. -1.47. In the year 2002, what is the difference between the Value added (% of GDP) of Belgium and Value added (% of GDP) of Nepal?
Your answer should be very brief. -37.44. In the year 2002, what is the difference between the Value added (% of GDP) in Belgium and Value added (% of GDP) in United Kingdom?
Provide a succinct answer. 0.3. In the year 2002, what is the difference between the Value added (% of GDP) of Italy and Value added (% of GDP) of Nepal?
Ensure brevity in your answer.  -35.97. In the year 2002, what is the difference between the Value added (% of GDP) of Italy and Value added (% of GDP) of United Kingdom?
Offer a terse response. 1.78. In the year 2002, what is the difference between the Value added (% of GDP) of Nepal and Value added (% of GDP) of United Kingdom?
Offer a very short reply. 37.75. In the year 2003, what is the difference between the Value added (% of GDP) of Belgium and Value added (% of GDP) of Italy?
Offer a terse response. -1.46. In the year 2003, what is the difference between the Value added (% of GDP) in Belgium and Value added (% of GDP) in Nepal?
Give a very brief answer. -36.4. In the year 2003, what is the difference between the Value added (% of GDP) of Belgium and Value added (% of GDP) of United Kingdom?
Make the answer very short. 0.25. In the year 2003, what is the difference between the Value added (% of GDP) of Italy and Value added (% of GDP) of Nepal?
Your answer should be very brief. -34.94. In the year 2003, what is the difference between the Value added (% of GDP) of Italy and Value added (% of GDP) of United Kingdom?
Provide a short and direct response. 1.71. In the year 2003, what is the difference between the Value added (% of GDP) in Nepal and Value added (% of GDP) in United Kingdom?
Make the answer very short. 36.65. In the year 2004, what is the difference between the Value added (% of GDP) in Belgium and Value added (% of GDP) in Italy?
Offer a very short reply. -1.46. In the year 2004, what is the difference between the Value added (% of GDP) in Belgium and Value added (% of GDP) in Nepal?
Keep it short and to the point. -36.04. In the year 2004, what is the difference between the Value added (% of GDP) of Belgium and Value added (% of GDP) of United Kingdom?
Your answer should be compact. 0.24. In the year 2004, what is the difference between the Value added (% of GDP) of Italy and Value added (% of GDP) of Nepal?
Give a very brief answer. -34.58. In the year 2004, what is the difference between the Value added (% of GDP) in Italy and Value added (% of GDP) in United Kingdom?
Provide a short and direct response. 1.7. In the year 2004, what is the difference between the Value added (% of GDP) of Nepal and Value added (% of GDP) of United Kingdom?
Keep it short and to the point. 36.28. In the year 2005, what is the difference between the Value added (% of GDP) in Belgium and Value added (% of GDP) in Italy?
Your answer should be compact. -1.31. In the year 2005, what is the difference between the Value added (% of GDP) in Belgium and Value added (% of GDP) in Nepal?
Ensure brevity in your answer.  -35.41. In the year 2005, what is the difference between the Value added (% of GDP) of Belgium and Value added (% of GDP) of United Kingdom?
Your response must be concise. 0.27. In the year 2005, what is the difference between the Value added (% of GDP) in Italy and Value added (% of GDP) in Nepal?
Your response must be concise. -34.1. In the year 2005, what is the difference between the Value added (% of GDP) of Italy and Value added (% of GDP) of United Kingdom?
Ensure brevity in your answer.  1.59. In the year 2005, what is the difference between the Value added (% of GDP) of Nepal and Value added (% of GDP) of United Kingdom?
Your response must be concise. 35.69. In the year 2006, what is the difference between the Value added (% of GDP) in Belgium and Value added (% of GDP) in Italy?
Give a very brief answer. -1.15. In the year 2006, what is the difference between the Value added (% of GDP) of Belgium and Value added (% of GDP) of Nepal?
Ensure brevity in your answer.  -33.63. In the year 2006, what is the difference between the Value added (% of GDP) of Belgium and Value added (% of GDP) of United Kingdom?
Make the answer very short. 0.37. In the year 2006, what is the difference between the Value added (% of GDP) of Italy and Value added (% of GDP) of Nepal?
Offer a very short reply. -32.48. In the year 2006, what is the difference between the Value added (% of GDP) in Italy and Value added (% of GDP) in United Kingdom?
Ensure brevity in your answer.  1.52. In the year 2007, what is the difference between the Value added (% of GDP) in Belgium and Value added (% of GDP) in Italy?
Ensure brevity in your answer.  -1.11. In the year 2007, what is the difference between the Value added (% of GDP) of Belgium and Value added (% of GDP) of Nepal?
Your response must be concise. -32.57. In the year 2007, what is the difference between the Value added (% of GDP) in Belgium and Value added (% of GDP) in United Kingdom?
Offer a terse response. 0.34. In the year 2007, what is the difference between the Value added (% of GDP) of Italy and Value added (% of GDP) of Nepal?
Ensure brevity in your answer.  -31.46. In the year 2007, what is the difference between the Value added (% of GDP) in Italy and Value added (% of GDP) in United Kingdom?
Offer a very short reply. 1.45. In the year 2007, what is the difference between the Value added (% of GDP) in Nepal and Value added (% of GDP) in United Kingdom?
Offer a terse response. 32.91. What is the ratio of the Value added (% of GDP) in Belgium in 2000 to that in 2001?
Provide a succinct answer. 1.06. What is the ratio of the Value added (% of GDP) in Italy in 2000 to that in 2001?
Your answer should be very brief. 1.03. What is the ratio of the Value added (% of GDP) in Nepal in 2000 to that in 2001?
Offer a terse response. 1.08. What is the ratio of the Value added (% of GDP) in United Kingdom in 2000 to that in 2001?
Offer a terse response. 1.05. What is the ratio of the Value added (% of GDP) of Belgium in 2000 to that in 2002?
Your answer should be compact. 1.14. What is the ratio of the Value added (% of GDP) of Italy in 2000 to that in 2002?
Give a very brief answer. 1.09. What is the ratio of the Value added (% of GDP) in Nepal in 2000 to that in 2002?
Provide a short and direct response. 1.06. What is the ratio of the Value added (% of GDP) of United Kingdom in 2000 to that in 2002?
Provide a succinct answer. 1.09. What is the ratio of the Value added (% of GDP) of Belgium in 2000 to that in 2003?
Offer a terse response. 1.15. What is the ratio of the Value added (% of GDP) in Italy in 2000 to that in 2003?
Your answer should be very brief. 1.1. What is the ratio of the Value added (% of GDP) of Nepal in 2000 to that in 2003?
Your response must be concise. 1.09. What is the ratio of the Value added (% of GDP) of United Kingdom in 2000 to that in 2003?
Your answer should be very brief. 1.04. What is the ratio of the Value added (% of GDP) in Belgium in 2000 to that in 2004?
Your answer should be very brief. 1.15. What is the ratio of the Value added (% of GDP) in Italy in 2000 to that in 2004?
Give a very brief answer. 1.1. What is the ratio of the Value added (% of GDP) in Nepal in 2000 to that in 2004?
Make the answer very short. 1.1. What is the ratio of the Value added (% of GDP) of United Kingdom in 2000 to that in 2004?
Offer a very short reply. 1.03. What is the ratio of the Value added (% of GDP) in Belgium in 2000 to that in 2005?
Provide a short and direct response. 1.4. What is the ratio of the Value added (% of GDP) of Italy in 2000 to that in 2005?
Provide a short and direct response. 1.27. What is the ratio of the Value added (% of GDP) of Nepal in 2000 to that in 2005?
Offer a terse response. 1.12. What is the ratio of the Value added (% of GDP) in United Kingdom in 2000 to that in 2005?
Provide a succinct answer. 1.39. What is the ratio of the Value added (% of GDP) in Belgium in 2000 to that in 2006?
Your response must be concise. 1.29. What is the ratio of the Value added (% of GDP) in Italy in 2000 to that in 2006?
Provide a succinct answer. 1.32. What is the ratio of the Value added (% of GDP) in Nepal in 2000 to that in 2006?
Offer a terse response. 1.18. What is the ratio of the Value added (% of GDP) of United Kingdom in 2000 to that in 2006?
Provide a succinct answer. 1.43. What is the ratio of the Value added (% of GDP) of Belgium in 2000 to that in 2007?
Your answer should be compact. 1.32. What is the ratio of the Value added (% of GDP) of Italy in 2000 to that in 2007?
Make the answer very short. 1.35. What is the ratio of the Value added (% of GDP) of Nepal in 2000 to that in 2007?
Your answer should be very brief. 1.22. What is the ratio of the Value added (% of GDP) of United Kingdom in 2000 to that in 2007?
Make the answer very short. 1.41. What is the ratio of the Value added (% of GDP) in Belgium in 2001 to that in 2002?
Your response must be concise. 1.07. What is the ratio of the Value added (% of GDP) of Italy in 2001 to that in 2002?
Your response must be concise. 1.05. What is the ratio of the Value added (% of GDP) of Nepal in 2001 to that in 2002?
Keep it short and to the point. 0.98. What is the ratio of the Value added (% of GDP) in United Kingdom in 2001 to that in 2002?
Keep it short and to the point. 1.03. What is the ratio of the Value added (% of GDP) in Belgium in 2001 to that in 2003?
Your answer should be very brief. 1.08. What is the ratio of the Value added (% of GDP) in Italy in 2001 to that in 2003?
Your answer should be compact. 1.06. What is the ratio of the Value added (% of GDP) in United Kingdom in 2001 to that in 2003?
Make the answer very short. 0.98. What is the ratio of the Value added (% of GDP) in Belgium in 2001 to that in 2004?
Your answer should be compact. 1.08. What is the ratio of the Value added (% of GDP) in Italy in 2001 to that in 2004?
Offer a very short reply. 1.06. What is the ratio of the Value added (% of GDP) in Nepal in 2001 to that in 2004?
Keep it short and to the point. 1.01. What is the ratio of the Value added (% of GDP) of United Kingdom in 2001 to that in 2004?
Keep it short and to the point. 0.98. What is the ratio of the Value added (% of GDP) in Belgium in 2001 to that in 2005?
Provide a succinct answer. 1.31. What is the ratio of the Value added (% of GDP) in Italy in 2001 to that in 2005?
Your answer should be compact. 1.22. What is the ratio of the Value added (% of GDP) of Nepal in 2001 to that in 2005?
Provide a succinct answer. 1.04. What is the ratio of the Value added (% of GDP) in United Kingdom in 2001 to that in 2005?
Offer a very short reply. 1.32. What is the ratio of the Value added (% of GDP) in Belgium in 2001 to that in 2006?
Your response must be concise. 1.22. What is the ratio of the Value added (% of GDP) in Italy in 2001 to that in 2006?
Offer a terse response. 1.27. What is the ratio of the Value added (% of GDP) in Nepal in 2001 to that in 2006?
Ensure brevity in your answer.  1.09. What is the ratio of the Value added (% of GDP) of United Kingdom in 2001 to that in 2006?
Provide a short and direct response. 1.36. What is the ratio of the Value added (% of GDP) in Belgium in 2001 to that in 2007?
Make the answer very short. 1.24. What is the ratio of the Value added (% of GDP) in Italy in 2001 to that in 2007?
Your response must be concise. 1.31. What is the ratio of the Value added (% of GDP) in Nepal in 2001 to that in 2007?
Ensure brevity in your answer.  1.12. What is the ratio of the Value added (% of GDP) of United Kingdom in 2001 to that in 2007?
Offer a terse response. 1.34. What is the ratio of the Value added (% of GDP) of Belgium in 2002 to that in 2003?
Your response must be concise. 1. What is the ratio of the Value added (% of GDP) of Italy in 2002 to that in 2003?
Offer a very short reply. 1.01. What is the ratio of the Value added (% of GDP) of Nepal in 2002 to that in 2003?
Your answer should be very brief. 1.03. What is the ratio of the Value added (% of GDP) of United Kingdom in 2002 to that in 2003?
Offer a very short reply. 0.95. What is the ratio of the Value added (% of GDP) of Italy in 2002 to that in 2004?
Offer a terse response. 1.01. What is the ratio of the Value added (% of GDP) in Nepal in 2002 to that in 2004?
Keep it short and to the point. 1.04. What is the ratio of the Value added (% of GDP) of United Kingdom in 2002 to that in 2004?
Give a very brief answer. 0.94. What is the ratio of the Value added (% of GDP) in Belgium in 2002 to that in 2005?
Offer a very short reply. 1.22. What is the ratio of the Value added (% of GDP) of Italy in 2002 to that in 2005?
Offer a very short reply. 1.16. What is the ratio of the Value added (% of GDP) in Nepal in 2002 to that in 2005?
Provide a succinct answer. 1.06. What is the ratio of the Value added (% of GDP) in United Kingdom in 2002 to that in 2005?
Offer a very short reply. 1.27. What is the ratio of the Value added (% of GDP) in Belgium in 2002 to that in 2006?
Your response must be concise. 1.13. What is the ratio of the Value added (% of GDP) in Italy in 2002 to that in 2006?
Offer a terse response. 1.21. What is the ratio of the Value added (% of GDP) of Nepal in 2002 to that in 2006?
Keep it short and to the point. 1.11. What is the ratio of the Value added (% of GDP) in United Kingdom in 2002 to that in 2006?
Your response must be concise. 1.31. What is the ratio of the Value added (% of GDP) of Belgium in 2002 to that in 2007?
Provide a short and direct response. 1.16. What is the ratio of the Value added (% of GDP) in Italy in 2002 to that in 2007?
Your answer should be compact. 1.24. What is the ratio of the Value added (% of GDP) in Nepal in 2002 to that in 2007?
Offer a terse response. 1.15. What is the ratio of the Value added (% of GDP) of United Kingdom in 2002 to that in 2007?
Make the answer very short. 1.3. What is the ratio of the Value added (% of GDP) in Italy in 2003 to that in 2004?
Ensure brevity in your answer.  1. What is the ratio of the Value added (% of GDP) of Nepal in 2003 to that in 2004?
Your answer should be very brief. 1.01. What is the ratio of the Value added (% of GDP) in United Kingdom in 2003 to that in 2004?
Make the answer very short. 0.99. What is the ratio of the Value added (% of GDP) in Belgium in 2003 to that in 2005?
Your answer should be compact. 1.22. What is the ratio of the Value added (% of GDP) in Italy in 2003 to that in 2005?
Your response must be concise. 1.16. What is the ratio of the Value added (% of GDP) of Nepal in 2003 to that in 2005?
Your answer should be compact. 1.03. What is the ratio of the Value added (% of GDP) of United Kingdom in 2003 to that in 2005?
Make the answer very short. 1.34. What is the ratio of the Value added (% of GDP) in Belgium in 2003 to that in 2006?
Provide a short and direct response. 1.13. What is the ratio of the Value added (% of GDP) of Italy in 2003 to that in 2006?
Give a very brief answer. 1.2. What is the ratio of the Value added (% of GDP) in Nepal in 2003 to that in 2006?
Provide a succinct answer. 1.08. What is the ratio of the Value added (% of GDP) of United Kingdom in 2003 to that in 2006?
Keep it short and to the point. 1.38. What is the ratio of the Value added (% of GDP) of Belgium in 2003 to that in 2007?
Provide a short and direct response. 1.15. What is the ratio of the Value added (% of GDP) in Italy in 2003 to that in 2007?
Give a very brief answer. 1.23. What is the ratio of the Value added (% of GDP) in Nepal in 2003 to that in 2007?
Your answer should be compact. 1.12. What is the ratio of the Value added (% of GDP) of United Kingdom in 2003 to that in 2007?
Ensure brevity in your answer.  1.37. What is the ratio of the Value added (% of GDP) in Belgium in 2004 to that in 2005?
Give a very brief answer. 1.21. What is the ratio of the Value added (% of GDP) of Italy in 2004 to that in 2005?
Provide a succinct answer. 1.15. What is the ratio of the Value added (% of GDP) in Nepal in 2004 to that in 2005?
Give a very brief answer. 1.02. What is the ratio of the Value added (% of GDP) of United Kingdom in 2004 to that in 2005?
Ensure brevity in your answer.  1.35. What is the ratio of the Value added (% of GDP) of Belgium in 2004 to that in 2006?
Give a very brief answer. 1.12. What is the ratio of the Value added (% of GDP) in Italy in 2004 to that in 2006?
Your answer should be compact. 1.2. What is the ratio of the Value added (% of GDP) of Nepal in 2004 to that in 2006?
Make the answer very short. 1.07. What is the ratio of the Value added (% of GDP) of United Kingdom in 2004 to that in 2006?
Your response must be concise. 1.39. What is the ratio of the Value added (% of GDP) of Belgium in 2004 to that in 2007?
Offer a very short reply. 1.15. What is the ratio of the Value added (% of GDP) in Italy in 2004 to that in 2007?
Offer a very short reply. 1.23. What is the ratio of the Value added (% of GDP) of Nepal in 2004 to that in 2007?
Your response must be concise. 1.11. What is the ratio of the Value added (% of GDP) in United Kingdom in 2004 to that in 2007?
Offer a terse response. 1.38. What is the ratio of the Value added (% of GDP) in Belgium in 2005 to that in 2006?
Provide a short and direct response. 0.93. What is the ratio of the Value added (% of GDP) in Italy in 2005 to that in 2006?
Give a very brief answer. 1.04. What is the ratio of the Value added (% of GDP) in Nepal in 2005 to that in 2006?
Your answer should be very brief. 1.05. What is the ratio of the Value added (% of GDP) of United Kingdom in 2005 to that in 2006?
Your answer should be compact. 1.03. What is the ratio of the Value added (% of GDP) of Belgium in 2005 to that in 2007?
Provide a succinct answer. 0.94. What is the ratio of the Value added (% of GDP) in Italy in 2005 to that in 2007?
Keep it short and to the point. 1.07. What is the ratio of the Value added (% of GDP) in Nepal in 2005 to that in 2007?
Your response must be concise. 1.08. What is the ratio of the Value added (% of GDP) of United Kingdom in 2005 to that in 2007?
Offer a very short reply. 1.02. What is the ratio of the Value added (% of GDP) of Belgium in 2006 to that in 2007?
Provide a succinct answer. 1.02. What is the ratio of the Value added (% of GDP) of Italy in 2006 to that in 2007?
Offer a terse response. 1.03. What is the ratio of the Value added (% of GDP) in Nepal in 2006 to that in 2007?
Your answer should be compact. 1.03. What is the difference between the highest and the second highest Value added (% of GDP) in Belgium?
Offer a terse response. 0.08. What is the difference between the highest and the second highest Value added (% of GDP) of Italy?
Offer a terse response. 0.1. What is the difference between the highest and the second highest Value added (% of GDP) of Nepal?
Provide a short and direct response. 2.23. What is the difference between the highest and the second highest Value added (% of GDP) in United Kingdom?
Offer a very short reply. 0.02. What is the difference between the highest and the lowest Value added (% of GDP) in Belgium?
Your answer should be compact. 0.37. What is the difference between the highest and the lowest Value added (% of GDP) of Italy?
Make the answer very short. 0.74. What is the difference between the highest and the lowest Value added (% of GDP) in Nepal?
Make the answer very short. 7.26. What is the difference between the highest and the lowest Value added (% of GDP) in United Kingdom?
Give a very brief answer. 0.28. 